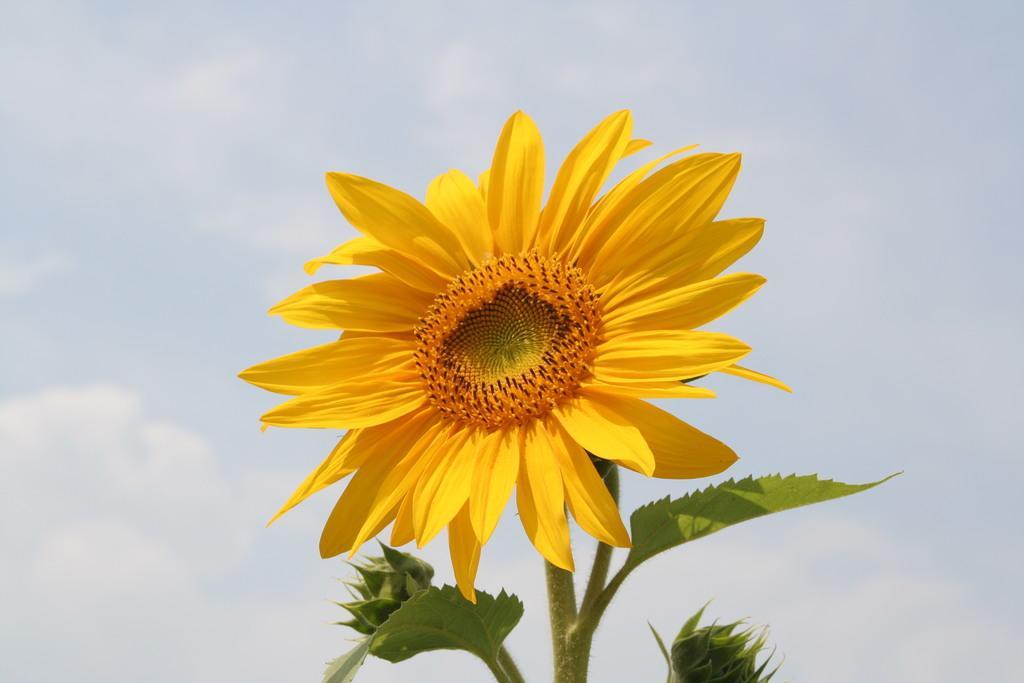Could you give a brief overview of what you see in this image? Here we can see a sunflower plant with a sunflower. In the background there are clouds in the sky. 